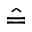Convert formula to latex. <formula><loc_0><loc_0><loc_500><loc_500>\hat { = }</formula> 